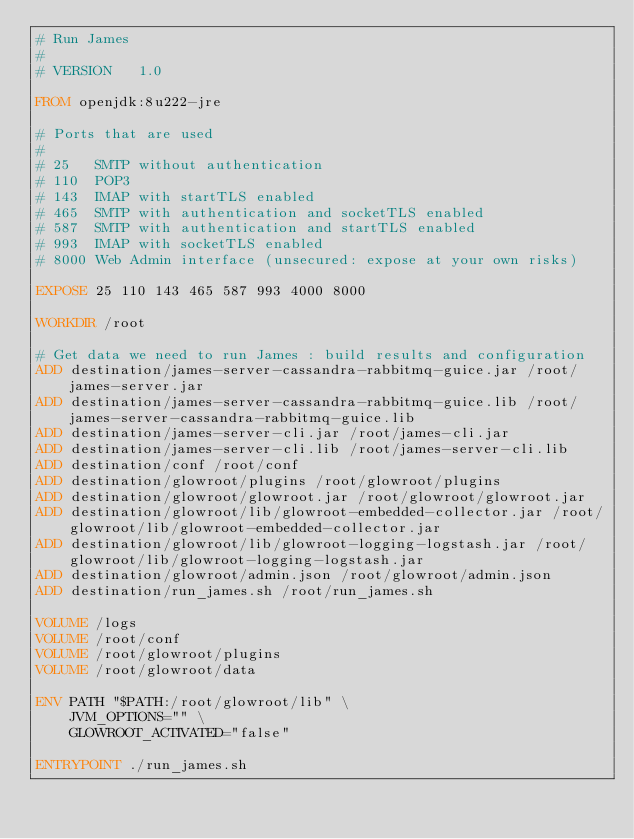<code> <loc_0><loc_0><loc_500><loc_500><_Dockerfile_># Run James
#
# VERSION	1.0

FROM openjdk:8u222-jre

# Ports that are used
#
# 25   SMTP without authentication
# 110  POP3
# 143  IMAP with startTLS enabled
# 465  SMTP with authentication and socketTLS enabled
# 587  SMTP with authentication and startTLS enabled
# 993  IMAP with socketTLS enabled
# 8000 Web Admin interface (unsecured: expose at your own risks)

EXPOSE 25 110 143 465 587 993 4000 8000

WORKDIR /root

# Get data we need to run James : build results and configuration
ADD destination/james-server-cassandra-rabbitmq-guice.jar /root/james-server.jar
ADD destination/james-server-cassandra-rabbitmq-guice.lib /root/james-server-cassandra-rabbitmq-guice.lib
ADD destination/james-server-cli.jar /root/james-cli.jar
ADD destination/james-server-cli.lib /root/james-server-cli.lib
ADD destination/conf /root/conf
ADD destination/glowroot/plugins /root/glowroot/plugins
ADD destination/glowroot/glowroot.jar /root/glowroot/glowroot.jar
ADD destination/glowroot/lib/glowroot-embedded-collector.jar /root/glowroot/lib/glowroot-embedded-collector.jar
ADD destination/glowroot/lib/glowroot-logging-logstash.jar /root/glowroot/lib/glowroot-logging-logstash.jar
ADD destination/glowroot/admin.json /root/glowroot/admin.json
ADD destination/run_james.sh /root/run_james.sh

VOLUME /logs
VOLUME /root/conf
VOLUME /root/glowroot/plugins
VOLUME /root/glowroot/data

ENV PATH "$PATH:/root/glowroot/lib" \
    JVM_OPTIONS="" \
    GLOWROOT_ACTIVATED="false"

ENTRYPOINT ./run_james.sh
</code> 